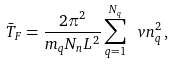<formula> <loc_0><loc_0><loc_500><loc_500>\bar { T } _ { F } = \frac { 2 \pi ^ { 2 } } { m _ { q } N _ { n } L ^ { 2 } } \sum _ { q = 1 } ^ { N _ { q } } \ v n ^ { 2 } _ { q } \, ,</formula> 